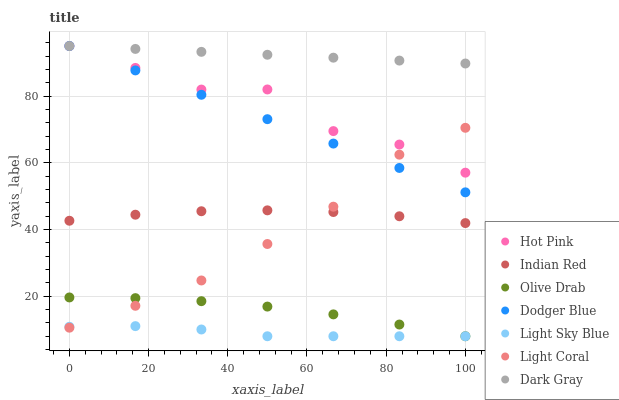Does Light Sky Blue have the minimum area under the curve?
Answer yes or no. Yes. Does Dark Gray have the maximum area under the curve?
Answer yes or no. Yes. Does Hot Pink have the minimum area under the curve?
Answer yes or no. No. Does Hot Pink have the maximum area under the curve?
Answer yes or no. No. Is Dark Gray the smoothest?
Answer yes or no. Yes. Is Hot Pink the roughest?
Answer yes or no. Yes. Is Light Coral the smoothest?
Answer yes or no. No. Is Light Coral the roughest?
Answer yes or no. No. Does Light Sky Blue have the lowest value?
Answer yes or no. Yes. Does Hot Pink have the lowest value?
Answer yes or no. No. Does Dodger Blue have the highest value?
Answer yes or no. Yes. Does Light Coral have the highest value?
Answer yes or no. No. Is Light Sky Blue less than Hot Pink?
Answer yes or no. Yes. Is Dodger Blue greater than Indian Red?
Answer yes or no. Yes. Does Dodger Blue intersect Hot Pink?
Answer yes or no. Yes. Is Dodger Blue less than Hot Pink?
Answer yes or no. No. Is Dodger Blue greater than Hot Pink?
Answer yes or no. No. Does Light Sky Blue intersect Hot Pink?
Answer yes or no. No. 